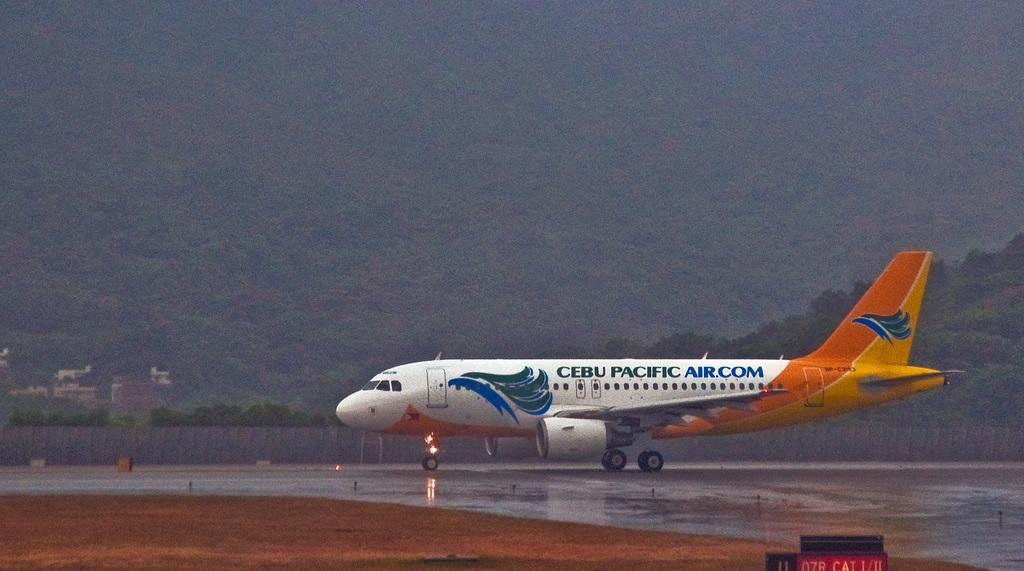<image>
Present a compact description of the photo's key features. a plane is shown with cebu pacific air.com on the side 